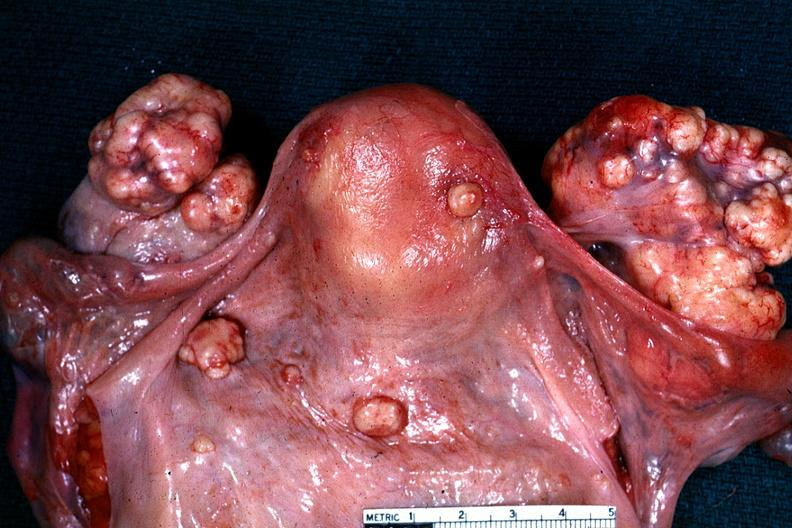what said to be an adenocarcinoma?
Answer the question using a single word or phrase. Excellent example of peritoneal carcinomatosis with implants on serosal surfaces of uterus and ovaries 